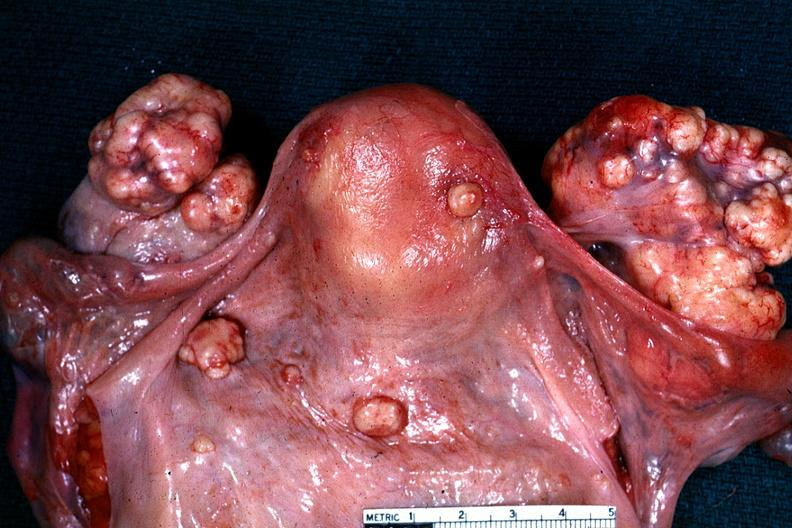what said to be an adenocarcinoma?
Answer the question using a single word or phrase. Excellent example of peritoneal carcinomatosis with implants on serosal surfaces of uterus and ovaries 